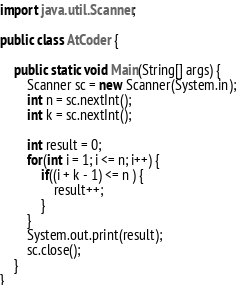<code> <loc_0><loc_0><loc_500><loc_500><_Java_>import java.util.Scanner;

public class AtCoder {

    public static void Main(String[] args) {
        Scanner sc = new Scanner(System.in);
        int n = sc.nextInt();
        int k = sc.nextInt();

        int result = 0;
        for(int i = 1; i <= n; i++) {
            if((i + k - 1) <= n ) {
                result++;
            }
        }
        System.out.print(result);
        sc.close();
    }
}</code> 